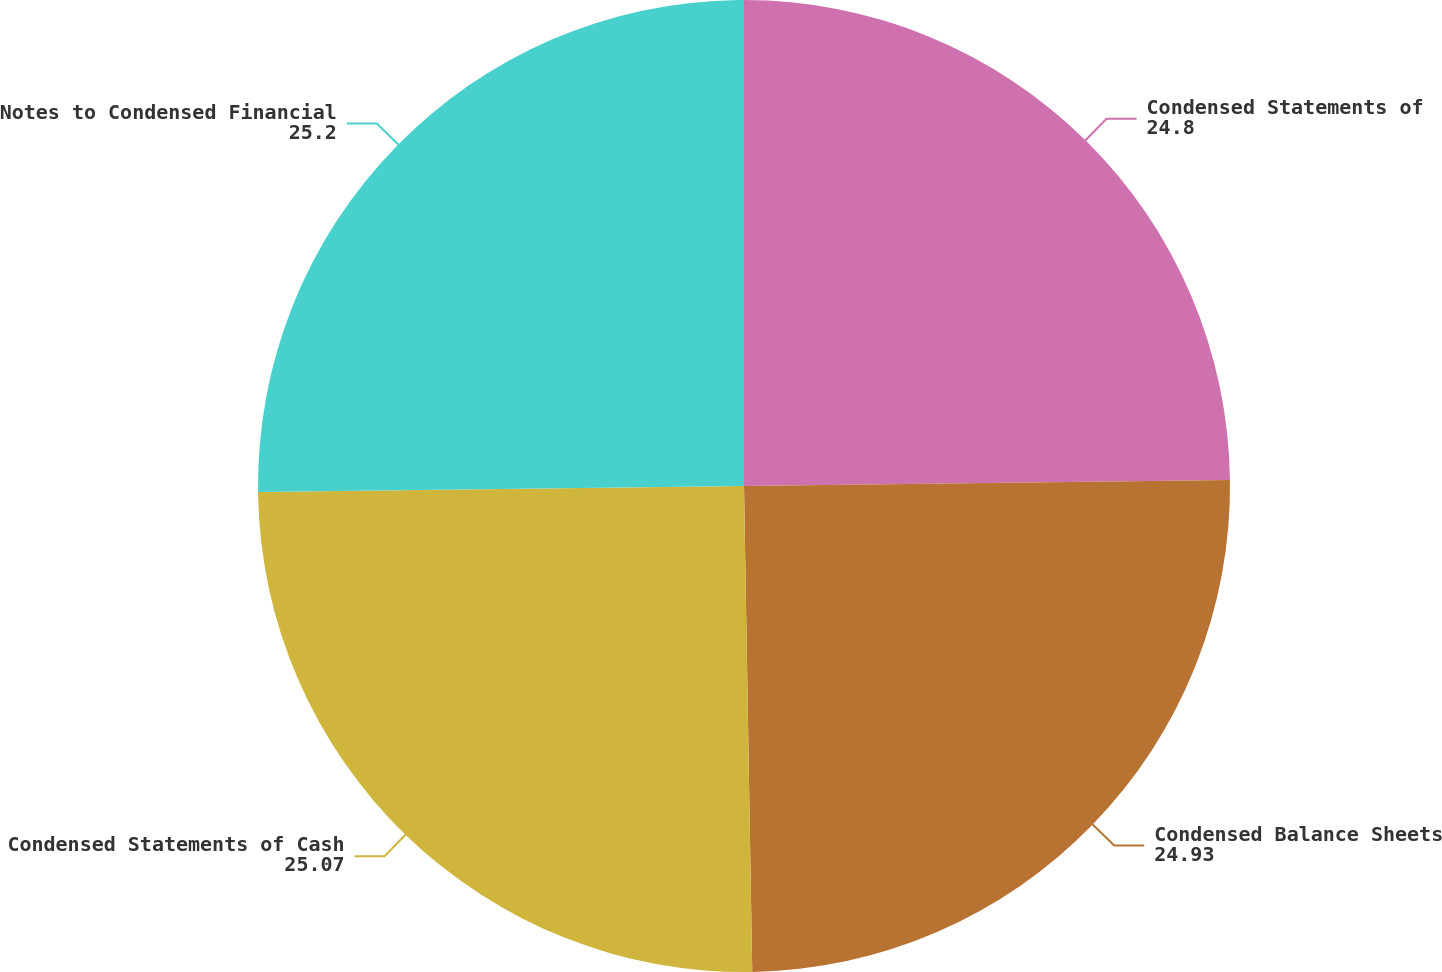Convert chart. <chart><loc_0><loc_0><loc_500><loc_500><pie_chart><fcel>Condensed Statements of<fcel>Condensed Balance Sheets<fcel>Condensed Statements of Cash<fcel>Notes to Condensed Financial<nl><fcel>24.8%<fcel>24.93%<fcel>25.07%<fcel>25.2%<nl></chart> 